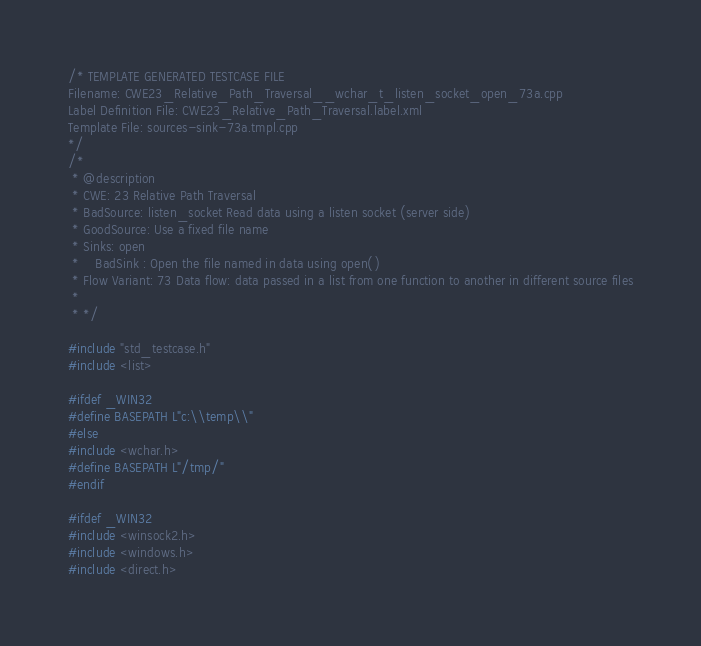Convert code to text. <code><loc_0><loc_0><loc_500><loc_500><_C++_>/* TEMPLATE GENERATED TESTCASE FILE
Filename: CWE23_Relative_Path_Traversal__wchar_t_listen_socket_open_73a.cpp
Label Definition File: CWE23_Relative_Path_Traversal.label.xml
Template File: sources-sink-73a.tmpl.cpp
*/
/*
 * @description
 * CWE: 23 Relative Path Traversal
 * BadSource: listen_socket Read data using a listen socket (server side)
 * GoodSource: Use a fixed file name
 * Sinks: open
 *    BadSink : Open the file named in data using open()
 * Flow Variant: 73 Data flow: data passed in a list from one function to another in different source files
 *
 * */

#include "std_testcase.h"
#include <list>

#ifdef _WIN32
#define BASEPATH L"c:\\temp\\"
#else
#include <wchar.h>
#define BASEPATH L"/tmp/"
#endif

#ifdef _WIN32
#include <winsock2.h>
#include <windows.h>
#include <direct.h></code> 